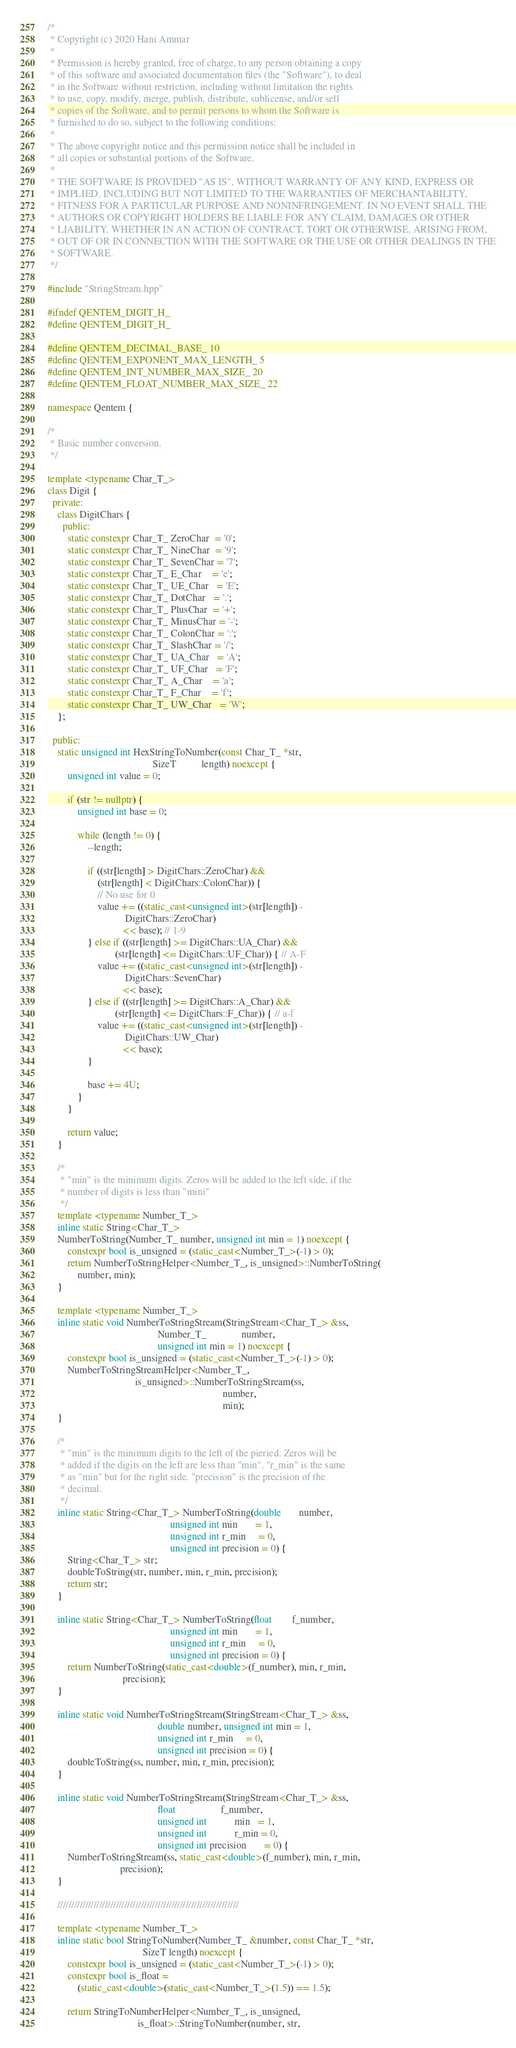<code> <loc_0><loc_0><loc_500><loc_500><_C++_>/*
 * Copyright (c) 2020 Hani Ammar
 *
 * Permission is hereby granted, free of charge, to any person obtaining a copy
 * of this software and associated documentation files (the "Software"), to deal
 * in the Software without restriction, including without limitation the rights
 * to use, copy, modify, merge, publish, distribute, sublicense, and/or sell
 * copies of the Software, and to permit persons to whom the Software is
 * furnished to do so, subject to the following conditions:
 *
 * The above copyright notice and this permission notice shall be included in
 * all copies or substantial portions of the Software.
 *
 * THE SOFTWARE IS PROVIDED "AS IS", WITHOUT WARRANTY OF ANY KIND, EXPRESS OR
 * IMPLIED, INCLUDING BUT NOT LIMITED TO THE WARRANTIES OF MERCHANTABILITY,
 * FITNESS FOR A PARTICULAR PURPOSE AND NONINFRINGEMENT. IN NO EVENT SHALL THE
 * AUTHORS OR COPYRIGHT HOLDERS BE LIABLE FOR ANY CLAIM, DAMAGES OR OTHER
 * LIABILITY, WHETHER IN AN ACTION OF CONTRACT, TORT OR OTHERWISE, ARISING FROM,
 * OUT OF OR IN CONNECTION WITH THE SOFTWARE OR THE USE OR OTHER DEALINGS IN THE
 * SOFTWARE.
 */

#include "StringStream.hpp"

#ifndef QENTEM_DIGIT_H_
#define QENTEM_DIGIT_H_

#define QENTEM_DECIMAL_BASE_ 10
#define QENTEM_EXPONENT_MAX_LENGTH_ 5
#define QENTEM_INT_NUMBER_MAX_SIZE_ 20
#define QENTEM_FLOAT_NUMBER_MAX_SIZE_ 22

namespace Qentem {

/*
 * Basic number conversion.
 */

template <typename Char_T_>
class Digit {
  private:
    class DigitChars {
      public:
        static constexpr Char_T_ ZeroChar  = '0';
        static constexpr Char_T_ NineChar  = '9';
        static constexpr Char_T_ SevenChar = '7';
        static constexpr Char_T_ E_Char    = 'e';
        static constexpr Char_T_ UE_Char   = 'E';
        static constexpr Char_T_ DotChar   = '.';
        static constexpr Char_T_ PlusChar  = '+';
        static constexpr Char_T_ MinusChar = '-';
        static constexpr Char_T_ ColonChar = ':';
        static constexpr Char_T_ SlashChar = '/';
        static constexpr Char_T_ UA_Char   = 'A';
        static constexpr Char_T_ UF_Char   = 'F';
        static constexpr Char_T_ A_Char    = 'a';
        static constexpr Char_T_ F_Char    = 'f';
        static constexpr Char_T_ UW_Char   = 'W';
    };

  public:
    static unsigned int HexStringToNumber(const Char_T_ *str,
                                          SizeT          length) noexcept {
        unsigned int value = 0;

        if (str != nullptr) {
            unsigned int base = 0;

            while (length != 0) {
                --length;

                if ((str[length] > DigitChars::ZeroChar) &&
                    (str[length] < DigitChars::ColonChar)) {
                    // No use for 0
                    value += ((static_cast<unsigned int>(str[length]) -
                               DigitChars::ZeroChar)
                              << base); // 1-9
                } else if ((str[length] >= DigitChars::UA_Char) &&
                           (str[length] <= DigitChars::UF_Char)) { // A-F
                    value += ((static_cast<unsigned int>(str[length]) -
                               DigitChars::SevenChar)
                              << base);
                } else if ((str[length] >= DigitChars::A_Char) &&
                           (str[length] <= DigitChars::F_Char)) { // a-f
                    value += ((static_cast<unsigned int>(str[length]) -
                               DigitChars::UW_Char)
                              << base);
                }

                base += 4U;
            }
        }

        return value;
    }

    /*
     * "min" is the minimum digits. Zeros will be added to the left side, if the
     * number of digits is less than "mini"
     */
    template <typename Number_T_>
    inline static String<Char_T_>
    NumberToString(Number_T_ number, unsigned int min = 1) noexcept {
        constexpr bool is_unsigned = (static_cast<Number_T_>(-1) > 0);
        return NumberToStringHelper<Number_T_, is_unsigned>::NumberToString(
            number, min);
    }

    template <typename Number_T_>
    inline static void NumberToStringStream(StringStream<Char_T_> &ss,
                                            Number_T_              number,
                                            unsigned int min = 1) noexcept {
        constexpr bool is_unsigned = (static_cast<Number_T_>(-1) > 0);
        NumberToStringStreamHelper<Number_T_,
                                   is_unsigned>::NumberToStringStream(ss,
                                                                      number,
                                                                      min);
    }

    /*
     * "min" is the minimum digits to the left of the pieried. Zeros will be
     * added if the digits on the left are less than "min". "r_min" is the same
     * as "min" but for the right side. "precision" is the precision of the
     * decimal.
     */
    inline static String<Char_T_> NumberToString(double       number,
                                                 unsigned int min       = 1,
                                                 unsigned int r_min     = 0,
                                                 unsigned int precision = 0) {
        String<Char_T_> str;
        doubleToString(str, number, min, r_min, precision);
        return str;
    }

    inline static String<Char_T_> NumberToString(float        f_number,
                                                 unsigned int min       = 1,
                                                 unsigned int r_min     = 0,
                                                 unsigned int precision = 0) {
        return NumberToString(static_cast<double>(f_number), min, r_min,
                              precision);
    }

    inline static void NumberToStringStream(StringStream<Char_T_> &ss,
                                            double number, unsigned int min = 1,
                                            unsigned int r_min     = 0,
                                            unsigned int precision = 0) {
        doubleToString(ss, number, min, r_min, precision);
    }

    inline static void NumberToStringStream(StringStream<Char_T_> &ss,
                                            float                  f_number,
                                            unsigned int           min   = 1,
                                            unsigned int           r_min = 0,
                                            unsigned int precision       = 0) {
        NumberToStringStream(ss, static_cast<double>(f_number), min, r_min,
                             precision);
    }

    /////////////////////////////////////////////////////////////////

    template <typename Number_T_>
    inline static bool StringToNumber(Number_T_ &number, const Char_T_ *str,
                                      SizeT length) noexcept {
        constexpr bool is_unsigned = (static_cast<Number_T_>(-1) > 0);
        constexpr bool is_float =
            (static_cast<double>(static_cast<Number_T_>(1.5)) == 1.5);

        return StringToNumberHelper<Number_T_, is_unsigned,
                                    is_float>::StringToNumber(number, str,</code> 